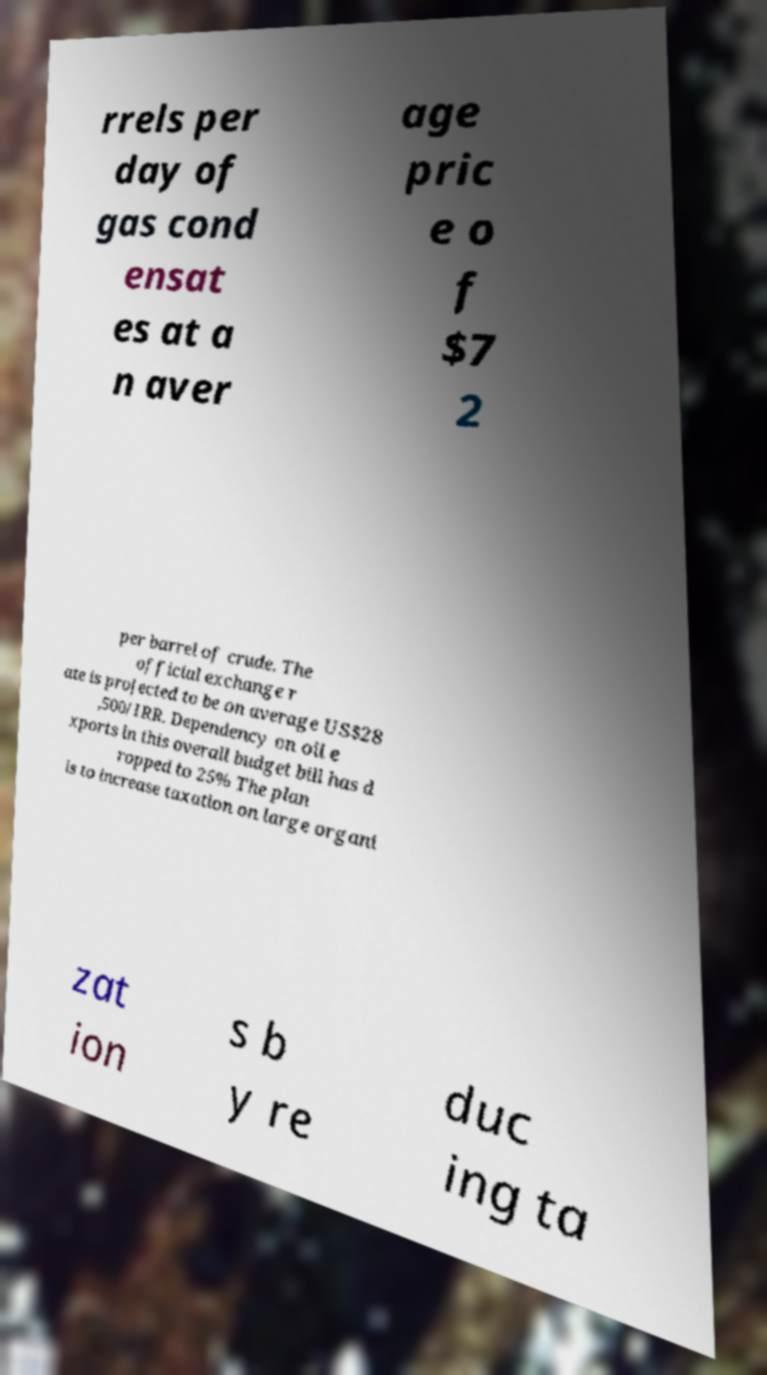Could you assist in decoding the text presented in this image and type it out clearly? rrels per day of gas cond ensat es at a n aver age pric e o f $7 2 per barrel of crude. The official exchange r ate is projected to be on average US$28 ,500/IRR. Dependency on oil e xports in this overall budget bill has d ropped to 25% The plan is to increase taxation on large organi zat ion s b y re duc ing ta 